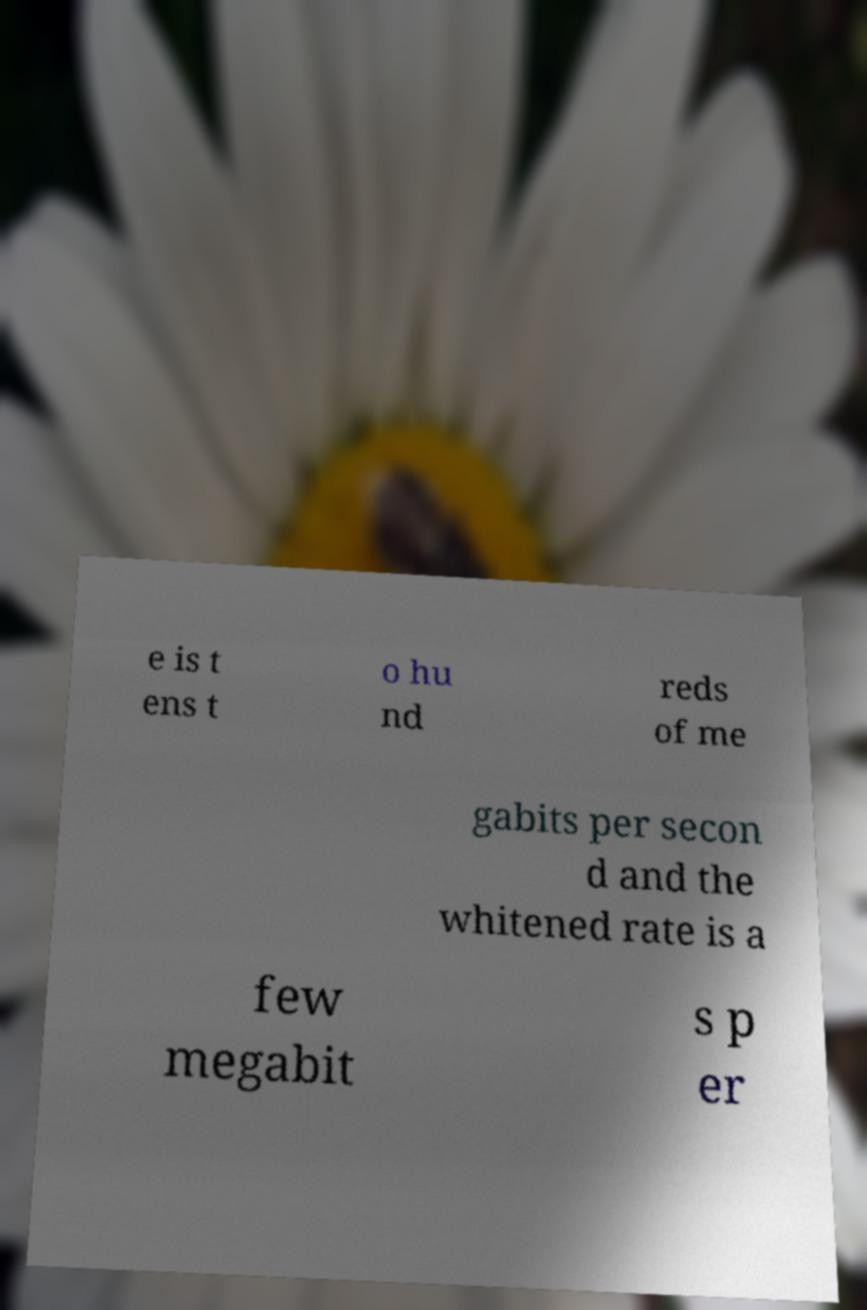What messages or text are displayed in this image? I need them in a readable, typed format. e is t ens t o hu nd reds of me gabits per secon d and the whitened rate is a few megabit s p er 